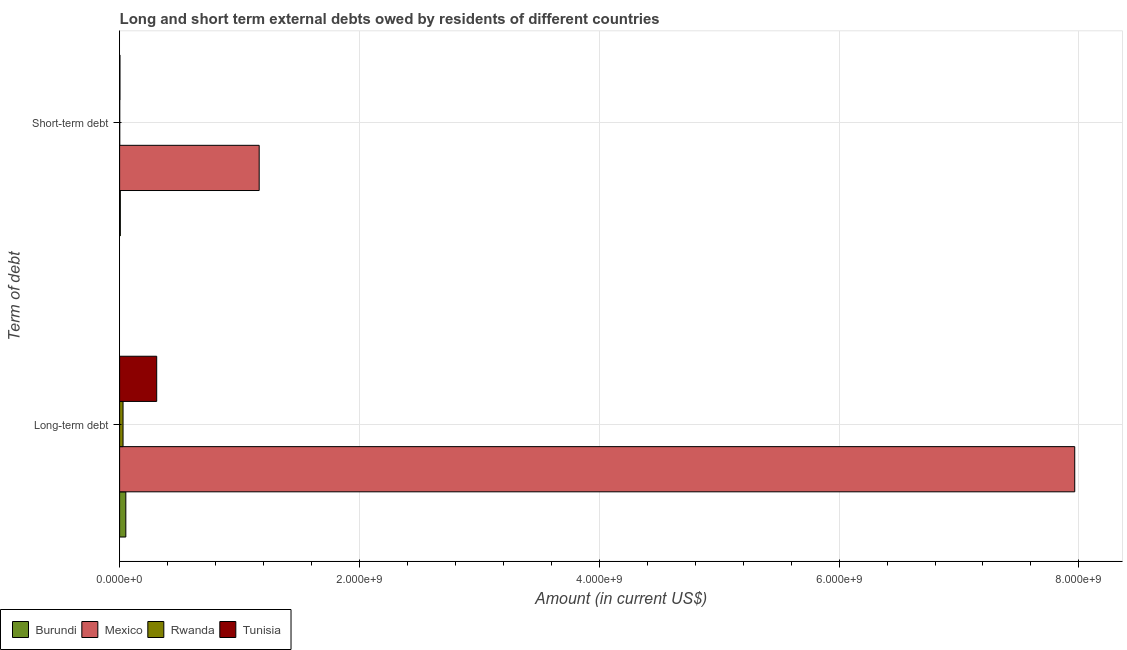How many groups of bars are there?
Offer a terse response. 2. Are the number of bars per tick equal to the number of legend labels?
Keep it short and to the point. Yes. How many bars are there on the 1st tick from the top?
Your answer should be very brief. 4. How many bars are there on the 2nd tick from the bottom?
Provide a short and direct response. 4. What is the label of the 2nd group of bars from the top?
Your response must be concise. Long-term debt. What is the long-term debts owed by residents in Tunisia?
Offer a very short reply. 3.09e+08. Across all countries, what is the maximum short-term debts owed by residents?
Ensure brevity in your answer.  1.16e+09. Across all countries, what is the minimum short-term debts owed by residents?
Give a very brief answer. 1.00e+06. In which country was the short-term debts owed by residents minimum?
Your response must be concise. Rwanda. What is the total short-term debts owed by residents in the graph?
Provide a short and direct response. 1.17e+09. What is the difference between the long-term debts owed by residents in Rwanda and that in Tunisia?
Provide a succinct answer. -2.81e+08. What is the difference between the long-term debts owed by residents in Burundi and the short-term debts owed by residents in Rwanda?
Provide a short and direct response. 5.08e+07. What is the average short-term debts owed by residents per country?
Give a very brief answer. 2.93e+08. What is the difference between the short-term debts owed by residents and long-term debts owed by residents in Burundi?
Your response must be concise. -4.58e+07. What is the ratio of the long-term debts owed by residents in Tunisia to that in Burundi?
Give a very brief answer. 5.97. In how many countries, is the long-term debts owed by residents greater than the average long-term debts owed by residents taken over all countries?
Your answer should be compact. 1. What does the 2nd bar from the bottom in Short-term debt represents?
Provide a succinct answer. Mexico. How many countries are there in the graph?
Give a very brief answer. 4. What is the difference between two consecutive major ticks on the X-axis?
Offer a terse response. 2.00e+09. Does the graph contain any zero values?
Make the answer very short. No. What is the title of the graph?
Provide a short and direct response. Long and short term external debts owed by residents of different countries. What is the label or title of the Y-axis?
Your answer should be very brief. Term of debt. What is the Amount (in current US$) of Burundi in Long-term debt?
Keep it short and to the point. 5.18e+07. What is the Amount (in current US$) of Mexico in Long-term debt?
Your answer should be very brief. 7.97e+09. What is the Amount (in current US$) in Rwanda in Long-term debt?
Your answer should be very brief. 2.87e+07. What is the Amount (in current US$) in Tunisia in Long-term debt?
Make the answer very short. 3.09e+08. What is the Amount (in current US$) of Burundi in Short-term debt?
Offer a terse response. 6.00e+06. What is the Amount (in current US$) of Mexico in Short-term debt?
Ensure brevity in your answer.  1.16e+09. What is the Amount (in current US$) in Rwanda in Short-term debt?
Your response must be concise. 1.00e+06. What is the Amount (in current US$) in Tunisia in Short-term debt?
Your answer should be very brief. 2.80e+06. Across all Term of debt, what is the maximum Amount (in current US$) of Burundi?
Make the answer very short. 5.18e+07. Across all Term of debt, what is the maximum Amount (in current US$) of Mexico?
Provide a succinct answer. 7.97e+09. Across all Term of debt, what is the maximum Amount (in current US$) of Rwanda?
Keep it short and to the point. 2.87e+07. Across all Term of debt, what is the maximum Amount (in current US$) of Tunisia?
Ensure brevity in your answer.  3.09e+08. Across all Term of debt, what is the minimum Amount (in current US$) of Mexico?
Offer a very short reply. 1.16e+09. Across all Term of debt, what is the minimum Amount (in current US$) of Tunisia?
Your answer should be very brief. 2.80e+06. What is the total Amount (in current US$) of Burundi in the graph?
Provide a short and direct response. 5.78e+07. What is the total Amount (in current US$) in Mexico in the graph?
Your response must be concise. 9.13e+09. What is the total Amount (in current US$) in Rwanda in the graph?
Give a very brief answer. 2.97e+07. What is the total Amount (in current US$) of Tunisia in the graph?
Offer a very short reply. 3.12e+08. What is the difference between the Amount (in current US$) of Burundi in Long-term debt and that in Short-term debt?
Ensure brevity in your answer.  4.58e+07. What is the difference between the Amount (in current US$) in Mexico in Long-term debt and that in Short-term debt?
Your answer should be compact. 6.80e+09. What is the difference between the Amount (in current US$) of Rwanda in Long-term debt and that in Short-term debt?
Make the answer very short. 2.77e+07. What is the difference between the Amount (in current US$) of Tunisia in Long-term debt and that in Short-term debt?
Give a very brief answer. 3.07e+08. What is the difference between the Amount (in current US$) of Burundi in Long-term debt and the Amount (in current US$) of Mexico in Short-term debt?
Keep it short and to the point. -1.11e+09. What is the difference between the Amount (in current US$) of Burundi in Long-term debt and the Amount (in current US$) of Rwanda in Short-term debt?
Offer a terse response. 5.08e+07. What is the difference between the Amount (in current US$) in Burundi in Long-term debt and the Amount (in current US$) in Tunisia in Short-term debt?
Your response must be concise. 4.90e+07. What is the difference between the Amount (in current US$) of Mexico in Long-term debt and the Amount (in current US$) of Rwanda in Short-term debt?
Provide a short and direct response. 7.96e+09. What is the difference between the Amount (in current US$) in Mexico in Long-term debt and the Amount (in current US$) in Tunisia in Short-term debt?
Keep it short and to the point. 7.96e+09. What is the difference between the Amount (in current US$) in Rwanda in Long-term debt and the Amount (in current US$) in Tunisia in Short-term debt?
Give a very brief answer. 2.59e+07. What is the average Amount (in current US$) in Burundi per Term of debt?
Your answer should be very brief. 2.89e+07. What is the average Amount (in current US$) of Mexico per Term of debt?
Your answer should be compact. 4.56e+09. What is the average Amount (in current US$) in Rwanda per Term of debt?
Offer a terse response. 1.48e+07. What is the average Amount (in current US$) in Tunisia per Term of debt?
Ensure brevity in your answer.  1.56e+08. What is the difference between the Amount (in current US$) in Burundi and Amount (in current US$) in Mexico in Long-term debt?
Your answer should be compact. -7.91e+09. What is the difference between the Amount (in current US$) of Burundi and Amount (in current US$) of Rwanda in Long-term debt?
Your response must be concise. 2.31e+07. What is the difference between the Amount (in current US$) in Burundi and Amount (in current US$) in Tunisia in Long-term debt?
Provide a short and direct response. -2.58e+08. What is the difference between the Amount (in current US$) of Mexico and Amount (in current US$) of Rwanda in Long-term debt?
Keep it short and to the point. 7.94e+09. What is the difference between the Amount (in current US$) of Mexico and Amount (in current US$) of Tunisia in Long-term debt?
Your answer should be very brief. 7.66e+09. What is the difference between the Amount (in current US$) in Rwanda and Amount (in current US$) in Tunisia in Long-term debt?
Offer a very short reply. -2.81e+08. What is the difference between the Amount (in current US$) of Burundi and Amount (in current US$) of Mexico in Short-term debt?
Make the answer very short. -1.16e+09. What is the difference between the Amount (in current US$) in Burundi and Amount (in current US$) in Tunisia in Short-term debt?
Provide a short and direct response. 3.20e+06. What is the difference between the Amount (in current US$) in Mexico and Amount (in current US$) in Rwanda in Short-term debt?
Offer a terse response. 1.16e+09. What is the difference between the Amount (in current US$) in Mexico and Amount (in current US$) in Tunisia in Short-term debt?
Keep it short and to the point. 1.16e+09. What is the difference between the Amount (in current US$) in Rwanda and Amount (in current US$) in Tunisia in Short-term debt?
Your response must be concise. -1.80e+06. What is the ratio of the Amount (in current US$) of Burundi in Long-term debt to that in Short-term debt?
Offer a very short reply. 8.63. What is the ratio of the Amount (in current US$) in Mexico in Long-term debt to that in Short-term debt?
Your response must be concise. 6.84. What is the ratio of the Amount (in current US$) of Rwanda in Long-term debt to that in Short-term debt?
Your answer should be compact. 28.65. What is the ratio of the Amount (in current US$) of Tunisia in Long-term debt to that in Short-term debt?
Offer a very short reply. 110.49. What is the difference between the highest and the second highest Amount (in current US$) of Burundi?
Give a very brief answer. 4.58e+07. What is the difference between the highest and the second highest Amount (in current US$) of Mexico?
Your answer should be compact. 6.80e+09. What is the difference between the highest and the second highest Amount (in current US$) in Rwanda?
Keep it short and to the point. 2.77e+07. What is the difference between the highest and the second highest Amount (in current US$) of Tunisia?
Keep it short and to the point. 3.07e+08. What is the difference between the highest and the lowest Amount (in current US$) of Burundi?
Provide a short and direct response. 4.58e+07. What is the difference between the highest and the lowest Amount (in current US$) in Mexico?
Keep it short and to the point. 6.80e+09. What is the difference between the highest and the lowest Amount (in current US$) of Rwanda?
Give a very brief answer. 2.77e+07. What is the difference between the highest and the lowest Amount (in current US$) of Tunisia?
Offer a terse response. 3.07e+08. 